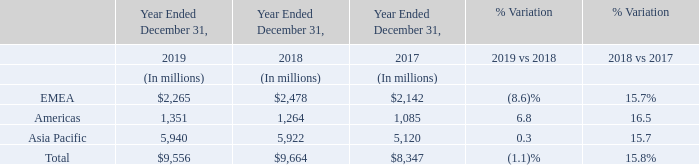Net revenues by location of shipment are classified by location of customer invoiced or reclassified by shipment destination in line with customer demand. For example, products ordered by U.S.-based companies to be invoiced to Asia Pacific affiliates are classified as Asia Pacific revenues.
By location of shipment, in 2019, revenues grew 6.8% in Americas, driven by Power Discrete, remained substantially flat in Asia and decreased 8.6% in EMEA, mainly due to lower sales of Microcontrollers and Power Discrete. In 2018 revenues grew across all regions, led by Asia Pacific and EMEA, mainly due to growth in Imaging and Automotive.
In 2019, how much revenue grew in Americas? 6.8%. In 2019, why did the revenue grew in Americas? Driven by power discrete. In 2018,why did the revenues grew across all regions? Mainly due to growth in imaging and automotive. What are the average net revenues by EMEA for Year Ended December 31?
Answer scale should be: million. (2,265+2,478+2,142) / 3
Answer: 2295. What are the average net revenues by Americas for Year Ended December 31?
Answer scale should be: million. (1,351+1,264+1,085) / 3
Answer: 1233.33. What are the average net revenues by Asia Pacific for Year Ended December 31?
Answer scale should be: million. (5,940+5,922+5,120) / 3
Answer: 5660.67. 